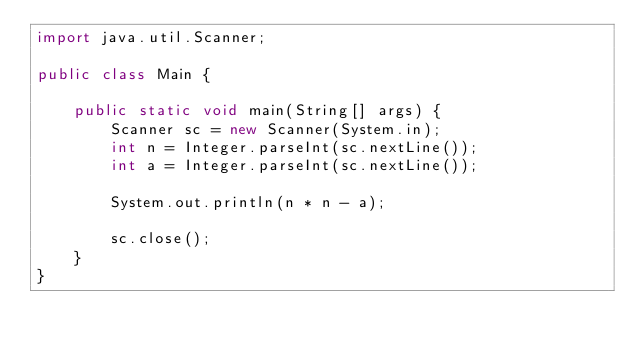<code> <loc_0><loc_0><loc_500><loc_500><_Java_>import java.util.Scanner;

public class Main {

	public static void main(String[] args) {
		Scanner sc = new Scanner(System.in);
		int n = Integer.parseInt(sc.nextLine());
		int a = Integer.parseInt(sc.nextLine());

		System.out.println(n * n - a);

		sc.close();
	}
}</code> 